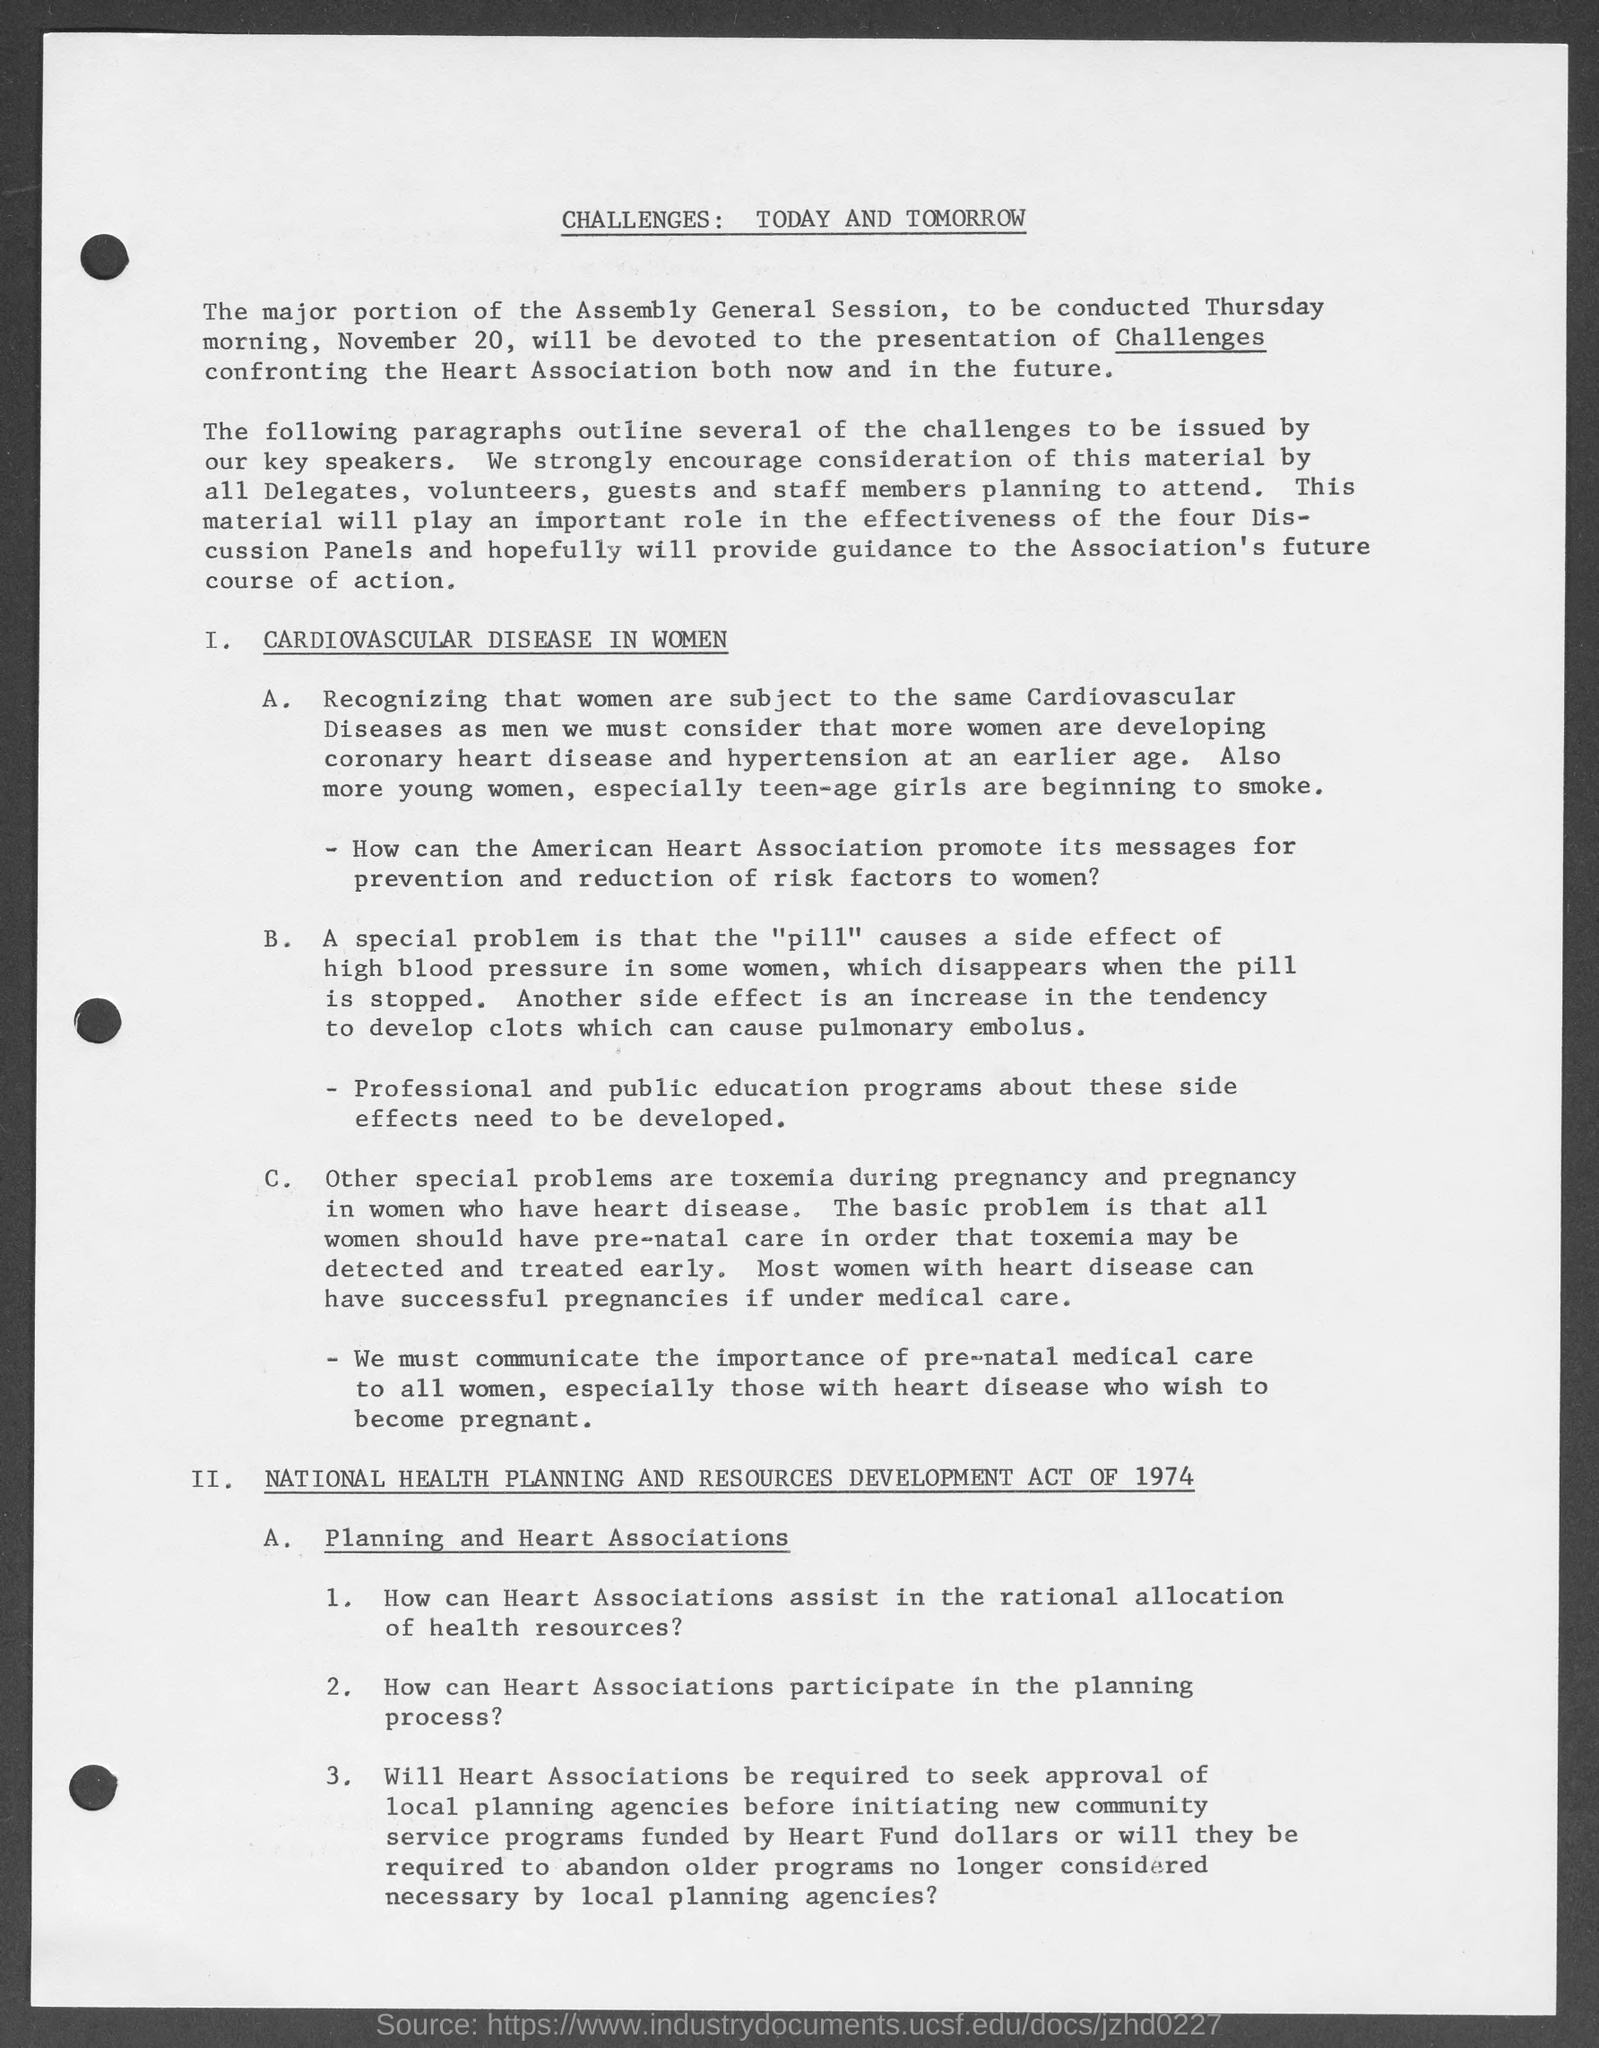Give some essential details in this illustration. The National Health Planning and Resources Development Act came into force in 1974. The general assembly session occurred on Thursday. The document mentions cardiovascular disease as a disease that primarily affects women. The use of certain medications, commonly referred to as "the pill," has been known to cause side effects such as an increase in blood pressure in some women. The heading of the document is 'Challenges: Today and Tomorrow.' 